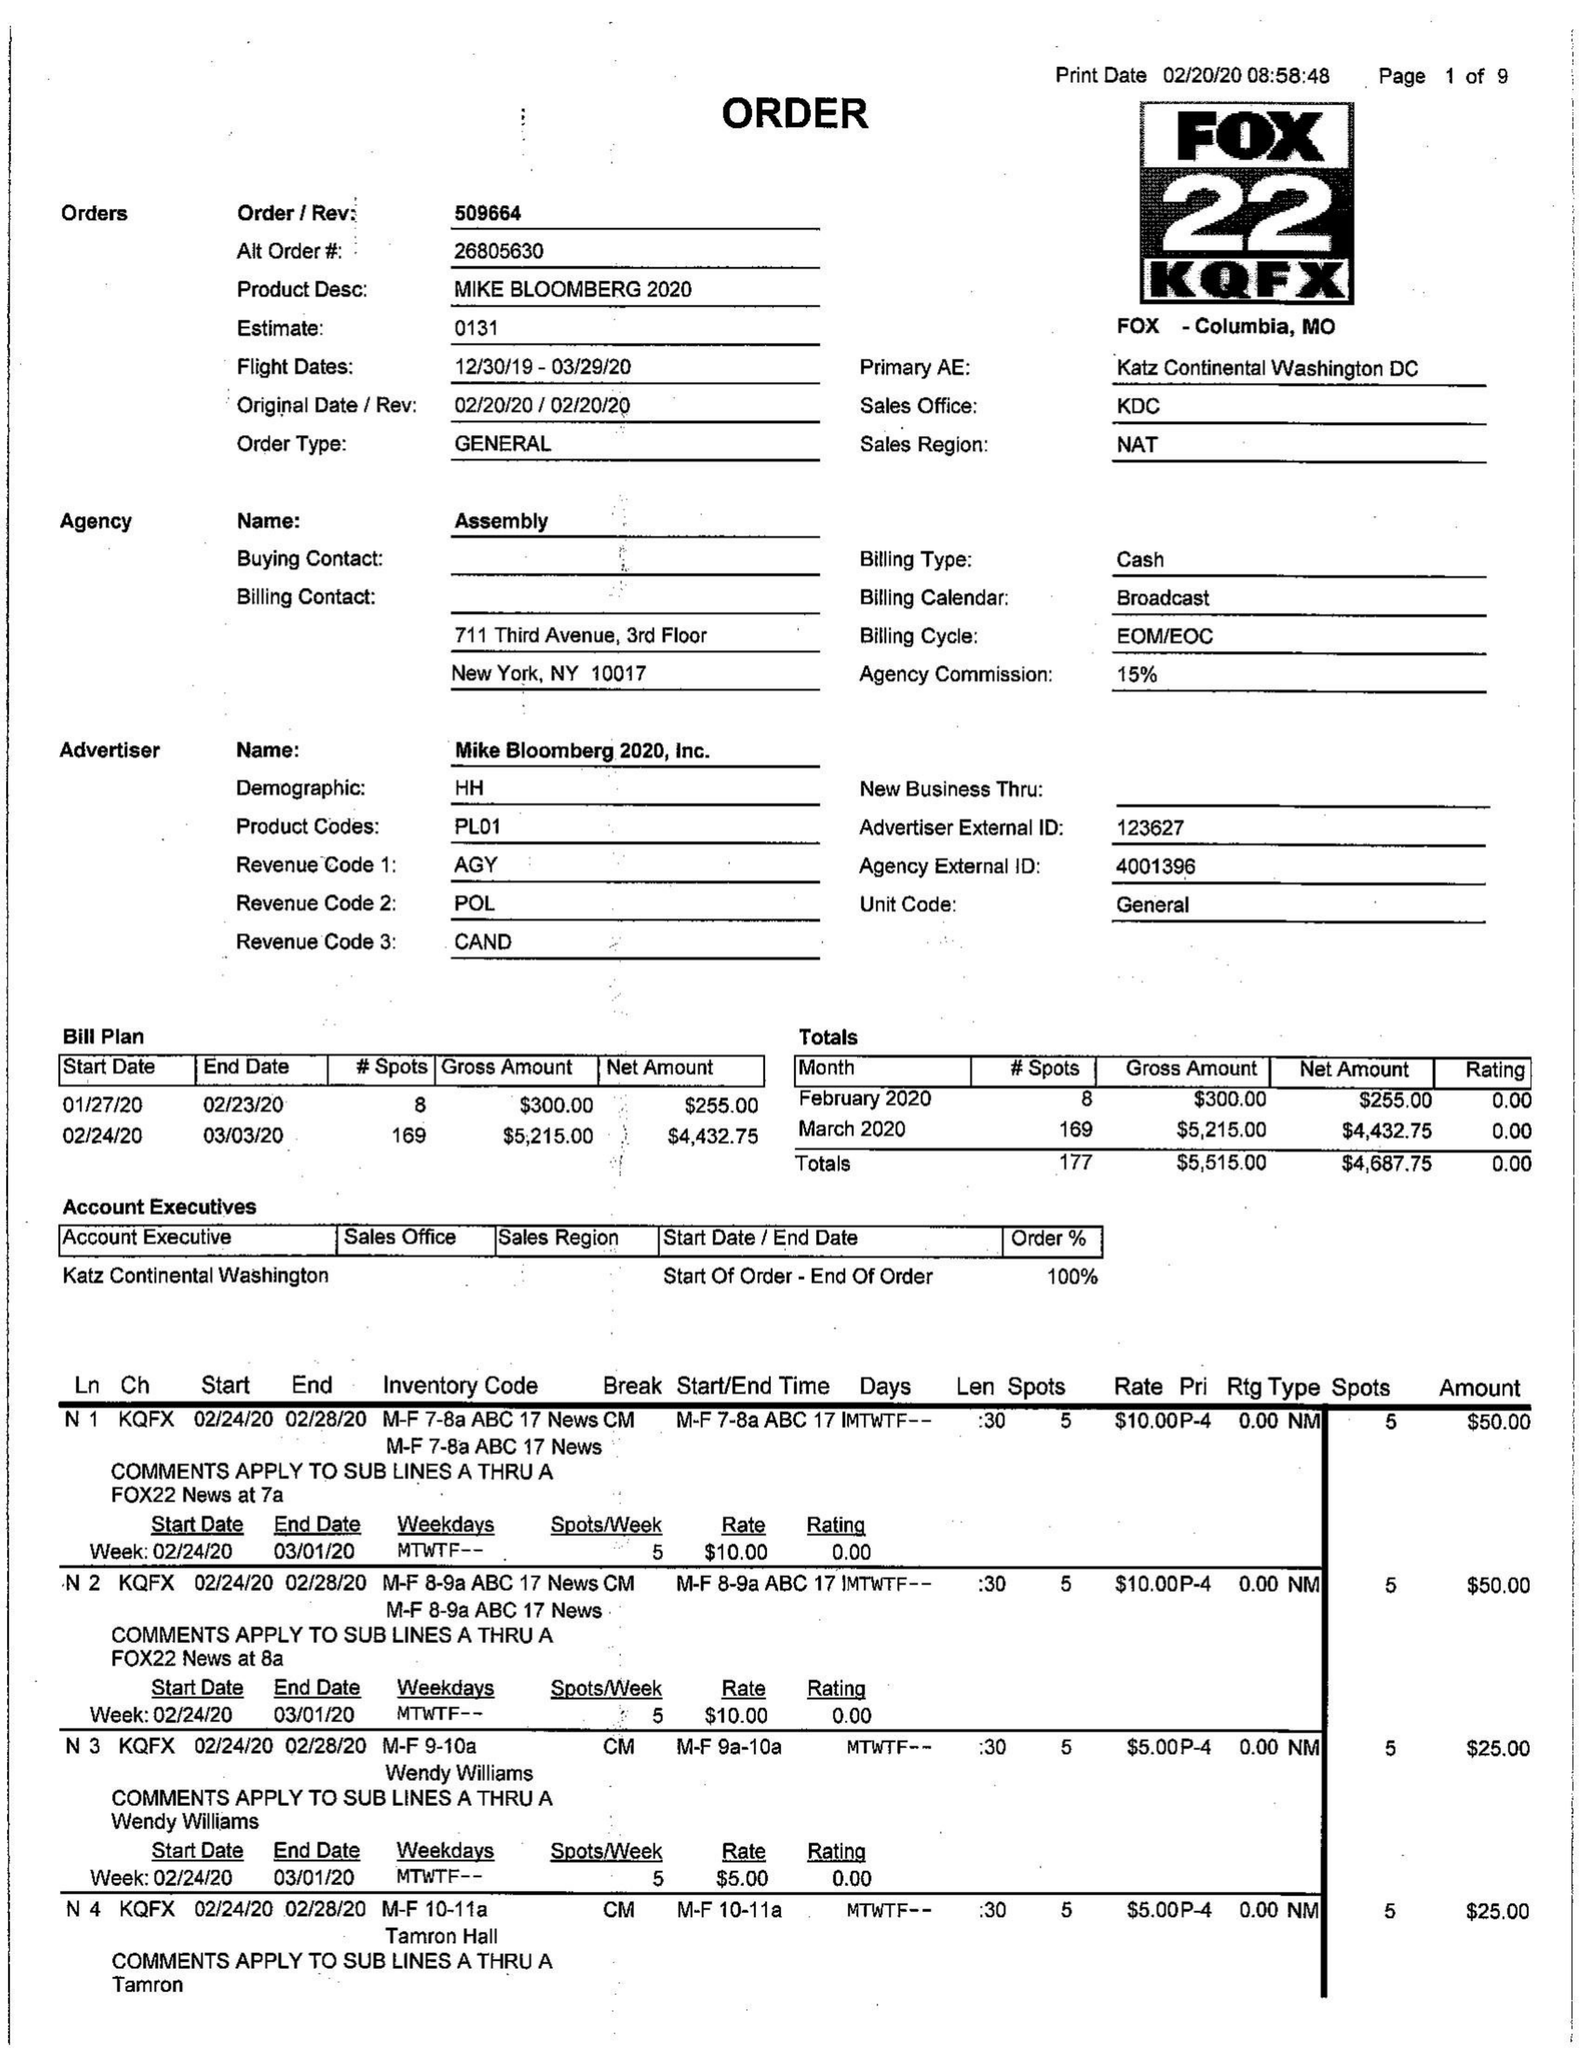What is the value for the flight_to?
Answer the question using a single word or phrase. 03/29/20 